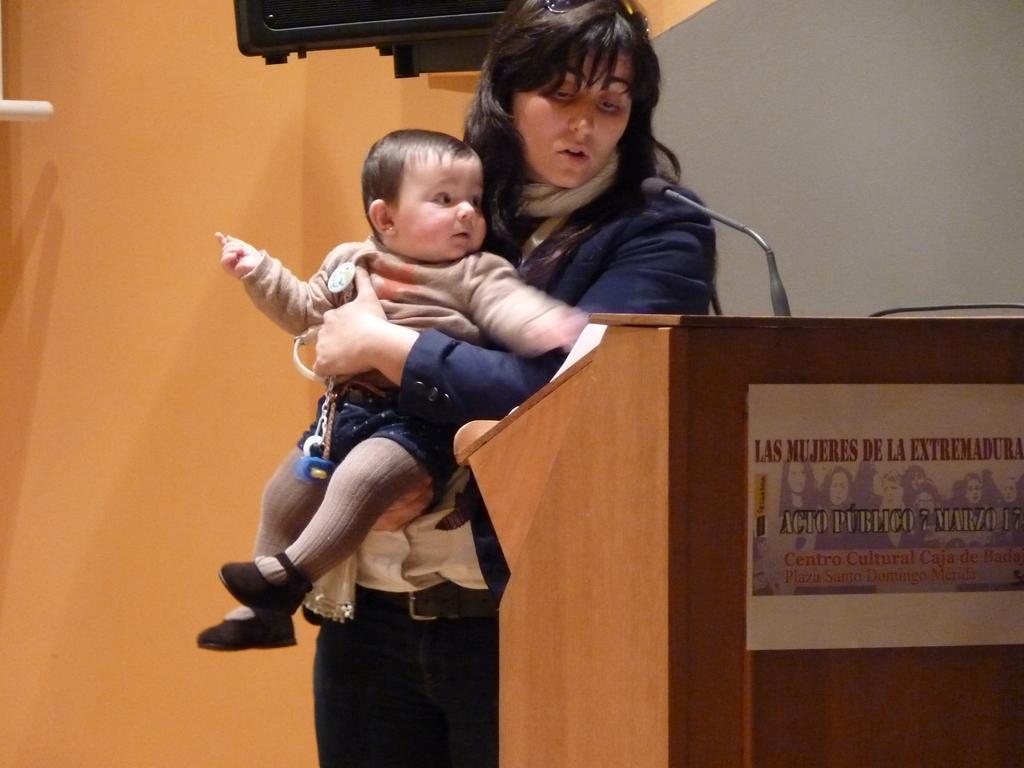In one or two sentences, can you explain what this image depicts? In this image there is a person holding the baby. In front of her there is a dais. On top of it there is a mike. In the background of the image there is a wall. In the center of the image there is a black color object. 